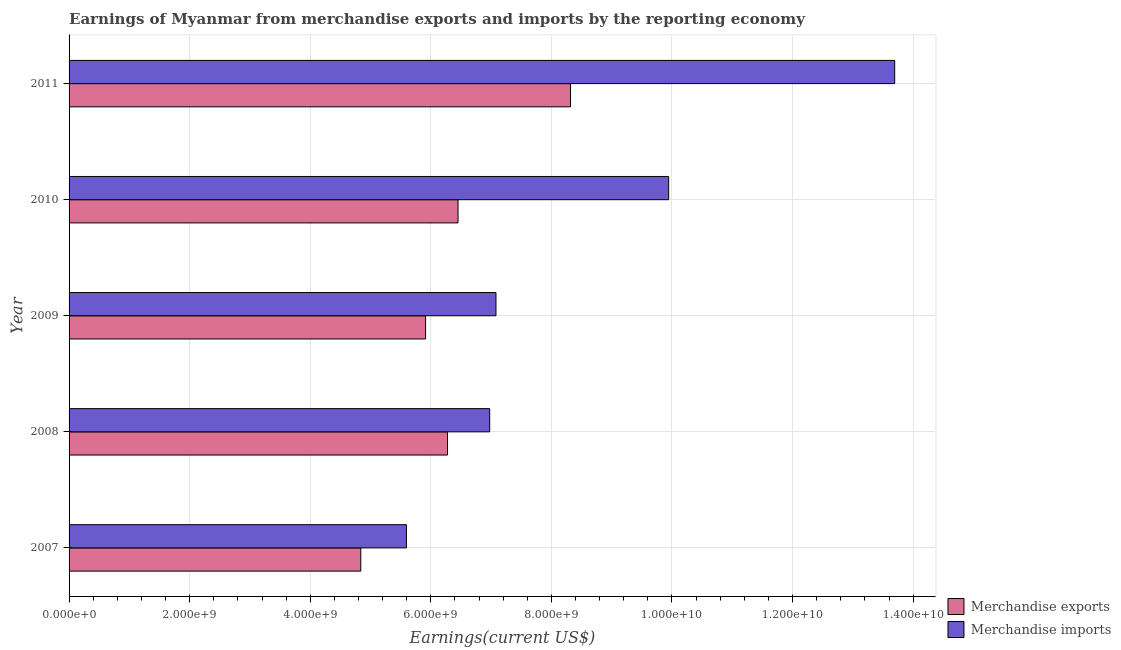How many groups of bars are there?
Provide a short and direct response. 5. Are the number of bars per tick equal to the number of legend labels?
Offer a terse response. Yes. Are the number of bars on each tick of the Y-axis equal?
Provide a short and direct response. Yes. What is the earnings from merchandise exports in 2009?
Give a very brief answer. 5.91e+09. Across all years, what is the maximum earnings from merchandise imports?
Give a very brief answer. 1.37e+1. Across all years, what is the minimum earnings from merchandise imports?
Give a very brief answer. 5.60e+09. In which year was the earnings from merchandise exports maximum?
Ensure brevity in your answer.  2011. In which year was the earnings from merchandise exports minimum?
Offer a terse response. 2007. What is the total earnings from merchandise imports in the graph?
Your answer should be very brief. 4.33e+1. What is the difference between the earnings from merchandise exports in 2008 and that in 2010?
Offer a very short reply. -1.74e+08. What is the difference between the earnings from merchandise exports in 2008 and the earnings from merchandise imports in 2009?
Your answer should be compact. -8.04e+08. What is the average earnings from merchandise imports per year?
Your answer should be very brief. 8.66e+09. In the year 2009, what is the difference between the earnings from merchandise exports and earnings from merchandise imports?
Offer a terse response. -1.17e+09. In how many years, is the earnings from merchandise imports greater than 6000000000 US$?
Your answer should be very brief. 4. What is the ratio of the earnings from merchandise imports in 2007 to that in 2011?
Your answer should be compact. 0.41. What is the difference between the highest and the second highest earnings from merchandise imports?
Your answer should be very brief. 3.75e+09. What is the difference between the highest and the lowest earnings from merchandise imports?
Provide a short and direct response. 8.10e+09. What does the 2nd bar from the top in 2010 represents?
Make the answer very short. Merchandise exports. What does the 1st bar from the bottom in 2011 represents?
Give a very brief answer. Merchandise exports. Are the values on the major ticks of X-axis written in scientific E-notation?
Offer a terse response. Yes. Does the graph contain any zero values?
Offer a terse response. No. Does the graph contain grids?
Ensure brevity in your answer.  Yes. Where does the legend appear in the graph?
Provide a succinct answer. Bottom right. How are the legend labels stacked?
Your response must be concise. Vertical. What is the title of the graph?
Provide a succinct answer. Earnings of Myanmar from merchandise exports and imports by the reporting economy. Does "Total Population" appear as one of the legend labels in the graph?
Ensure brevity in your answer.  No. What is the label or title of the X-axis?
Give a very brief answer. Earnings(current US$). What is the label or title of the Y-axis?
Your response must be concise. Year. What is the Earnings(current US$) in Merchandise exports in 2007?
Give a very brief answer. 4.84e+09. What is the Earnings(current US$) of Merchandise imports in 2007?
Provide a short and direct response. 5.60e+09. What is the Earnings(current US$) in Merchandise exports in 2008?
Offer a terse response. 6.28e+09. What is the Earnings(current US$) of Merchandise imports in 2008?
Make the answer very short. 6.98e+09. What is the Earnings(current US$) in Merchandise exports in 2009?
Give a very brief answer. 5.91e+09. What is the Earnings(current US$) of Merchandise imports in 2009?
Provide a succinct answer. 7.08e+09. What is the Earnings(current US$) in Merchandise exports in 2010?
Your answer should be compact. 6.45e+09. What is the Earnings(current US$) in Merchandise imports in 2010?
Your response must be concise. 9.94e+09. What is the Earnings(current US$) of Merchandise exports in 2011?
Give a very brief answer. 8.32e+09. What is the Earnings(current US$) of Merchandise imports in 2011?
Provide a succinct answer. 1.37e+1. Across all years, what is the maximum Earnings(current US$) in Merchandise exports?
Provide a short and direct response. 8.32e+09. Across all years, what is the maximum Earnings(current US$) of Merchandise imports?
Make the answer very short. 1.37e+1. Across all years, what is the minimum Earnings(current US$) of Merchandise exports?
Your answer should be very brief. 4.84e+09. Across all years, what is the minimum Earnings(current US$) of Merchandise imports?
Your answer should be compact. 5.60e+09. What is the total Earnings(current US$) of Merchandise exports in the graph?
Offer a very short reply. 3.18e+1. What is the total Earnings(current US$) of Merchandise imports in the graph?
Your response must be concise. 4.33e+1. What is the difference between the Earnings(current US$) of Merchandise exports in 2007 and that in 2008?
Your response must be concise. -1.44e+09. What is the difference between the Earnings(current US$) in Merchandise imports in 2007 and that in 2008?
Give a very brief answer. -1.38e+09. What is the difference between the Earnings(current US$) in Merchandise exports in 2007 and that in 2009?
Your response must be concise. -1.07e+09. What is the difference between the Earnings(current US$) in Merchandise imports in 2007 and that in 2009?
Offer a terse response. -1.49e+09. What is the difference between the Earnings(current US$) in Merchandise exports in 2007 and that in 2010?
Ensure brevity in your answer.  -1.61e+09. What is the difference between the Earnings(current US$) of Merchandise imports in 2007 and that in 2010?
Keep it short and to the point. -4.35e+09. What is the difference between the Earnings(current US$) of Merchandise exports in 2007 and that in 2011?
Ensure brevity in your answer.  -3.48e+09. What is the difference between the Earnings(current US$) in Merchandise imports in 2007 and that in 2011?
Keep it short and to the point. -8.10e+09. What is the difference between the Earnings(current US$) of Merchandise exports in 2008 and that in 2009?
Offer a very short reply. 3.64e+08. What is the difference between the Earnings(current US$) in Merchandise imports in 2008 and that in 2009?
Your answer should be very brief. -1.04e+08. What is the difference between the Earnings(current US$) of Merchandise exports in 2008 and that in 2010?
Provide a short and direct response. -1.74e+08. What is the difference between the Earnings(current US$) of Merchandise imports in 2008 and that in 2010?
Your response must be concise. -2.97e+09. What is the difference between the Earnings(current US$) of Merchandise exports in 2008 and that in 2011?
Offer a very short reply. -2.04e+09. What is the difference between the Earnings(current US$) in Merchandise imports in 2008 and that in 2011?
Your answer should be compact. -6.72e+09. What is the difference between the Earnings(current US$) in Merchandise exports in 2009 and that in 2010?
Offer a terse response. -5.39e+08. What is the difference between the Earnings(current US$) of Merchandise imports in 2009 and that in 2010?
Ensure brevity in your answer.  -2.86e+09. What is the difference between the Earnings(current US$) of Merchandise exports in 2009 and that in 2011?
Make the answer very short. -2.40e+09. What is the difference between the Earnings(current US$) in Merchandise imports in 2009 and that in 2011?
Your answer should be compact. -6.61e+09. What is the difference between the Earnings(current US$) in Merchandise exports in 2010 and that in 2011?
Offer a very short reply. -1.87e+09. What is the difference between the Earnings(current US$) of Merchandise imports in 2010 and that in 2011?
Provide a succinct answer. -3.75e+09. What is the difference between the Earnings(current US$) in Merchandise exports in 2007 and the Earnings(current US$) in Merchandise imports in 2008?
Give a very brief answer. -2.14e+09. What is the difference between the Earnings(current US$) in Merchandise exports in 2007 and the Earnings(current US$) in Merchandise imports in 2009?
Provide a short and direct response. -2.24e+09. What is the difference between the Earnings(current US$) of Merchandise exports in 2007 and the Earnings(current US$) of Merchandise imports in 2010?
Offer a very short reply. -5.11e+09. What is the difference between the Earnings(current US$) in Merchandise exports in 2007 and the Earnings(current US$) in Merchandise imports in 2011?
Your response must be concise. -8.86e+09. What is the difference between the Earnings(current US$) of Merchandise exports in 2008 and the Earnings(current US$) of Merchandise imports in 2009?
Make the answer very short. -8.04e+08. What is the difference between the Earnings(current US$) in Merchandise exports in 2008 and the Earnings(current US$) in Merchandise imports in 2010?
Offer a very short reply. -3.67e+09. What is the difference between the Earnings(current US$) of Merchandise exports in 2008 and the Earnings(current US$) of Merchandise imports in 2011?
Your answer should be very brief. -7.42e+09. What is the difference between the Earnings(current US$) in Merchandise exports in 2009 and the Earnings(current US$) in Merchandise imports in 2010?
Provide a short and direct response. -4.03e+09. What is the difference between the Earnings(current US$) of Merchandise exports in 2009 and the Earnings(current US$) of Merchandise imports in 2011?
Your answer should be compact. -7.78e+09. What is the difference between the Earnings(current US$) in Merchandise exports in 2010 and the Earnings(current US$) in Merchandise imports in 2011?
Keep it short and to the point. -7.24e+09. What is the average Earnings(current US$) in Merchandise exports per year?
Offer a very short reply. 6.36e+09. What is the average Earnings(current US$) of Merchandise imports per year?
Make the answer very short. 8.66e+09. In the year 2007, what is the difference between the Earnings(current US$) of Merchandise exports and Earnings(current US$) of Merchandise imports?
Offer a very short reply. -7.57e+08. In the year 2008, what is the difference between the Earnings(current US$) in Merchandise exports and Earnings(current US$) in Merchandise imports?
Keep it short and to the point. -6.99e+08. In the year 2009, what is the difference between the Earnings(current US$) in Merchandise exports and Earnings(current US$) in Merchandise imports?
Provide a succinct answer. -1.17e+09. In the year 2010, what is the difference between the Earnings(current US$) in Merchandise exports and Earnings(current US$) in Merchandise imports?
Offer a very short reply. -3.49e+09. In the year 2011, what is the difference between the Earnings(current US$) in Merchandise exports and Earnings(current US$) in Merchandise imports?
Your answer should be very brief. -5.38e+09. What is the ratio of the Earnings(current US$) of Merchandise exports in 2007 to that in 2008?
Give a very brief answer. 0.77. What is the ratio of the Earnings(current US$) of Merchandise imports in 2007 to that in 2008?
Make the answer very short. 0.8. What is the ratio of the Earnings(current US$) in Merchandise exports in 2007 to that in 2009?
Your answer should be compact. 0.82. What is the ratio of the Earnings(current US$) in Merchandise imports in 2007 to that in 2009?
Provide a succinct answer. 0.79. What is the ratio of the Earnings(current US$) in Merchandise imports in 2007 to that in 2010?
Your response must be concise. 0.56. What is the ratio of the Earnings(current US$) in Merchandise exports in 2007 to that in 2011?
Make the answer very short. 0.58. What is the ratio of the Earnings(current US$) of Merchandise imports in 2007 to that in 2011?
Your response must be concise. 0.41. What is the ratio of the Earnings(current US$) of Merchandise exports in 2008 to that in 2009?
Offer a very short reply. 1.06. What is the ratio of the Earnings(current US$) of Merchandise imports in 2008 to that in 2009?
Offer a very short reply. 0.99. What is the ratio of the Earnings(current US$) of Merchandise exports in 2008 to that in 2010?
Provide a short and direct response. 0.97. What is the ratio of the Earnings(current US$) of Merchandise imports in 2008 to that in 2010?
Your response must be concise. 0.7. What is the ratio of the Earnings(current US$) in Merchandise exports in 2008 to that in 2011?
Provide a short and direct response. 0.75. What is the ratio of the Earnings(current US$) of Merchandise imports in 2008 to that in 2011?
Your answer should be very brief. 0.51. What is the ratio of the Earnings(current US$) of Merchandise exports in 2009 to that in 2010?
Your response must be concise. 0.92. What is the ratio of the Earnings(current US$) of Merchandise imports in 2009 to that in 2010?
Your response must be concise. 0.71. What is the ratio of the Earnings(current US$) in Merchandise exports in 2009 to that in 2011?
Your response must be concise. 0.71. What is the ratio of the Earnings(current US$) in Merchandise imports in 2009 to that in 2011?
Provide a succinct answer. 0.52. What is the ratio of the Earnings(current US$) of Merchandise exports in 2010 to that in 2011?
Your answer should be very brief. 0.78. What is the ratio of the Earnings(current US$) in Merchandise imports in 2010 to that in 2011?
Your answer should be very brief. 0.73. What is the difference between the highest and the second highest Earnings(current US$) in Merchandise exports?
Keep it short and to the point. 1.87e+09. What is the difference between the highest and the second highest Earnings(current US$) in Merchandise imports?
Give a very brief answer. 3.75e+09. What is the difference between the highest and the lowest Earnings(current US$) of Merchandise exports?
Provide a short and direct response. 3.48e+09. What is the difference between the highest and the lowest Earnings(current US$) in Merchandise imports?
Provide a succinct answer. 8.10e+09. 